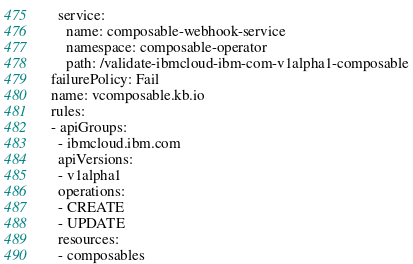<code> <loc_0><loc_0><loc_500><loc_500><_YAML_>    service:
      name: composable-webhook-service
      namespace: composable-operator
      path: /validate-ibmcloud-ibm-com-v1alpha1-composable
  failurePolicy: Fail
  name: vcomposable.kb.io
  rules:
  - apiGroups:
    - ibmcloud.ibm.com
    apiVersions:
    - v1alpha1
    operations:
    - CREATE
    - UPDATE
    resources:
    - composables
</code> 